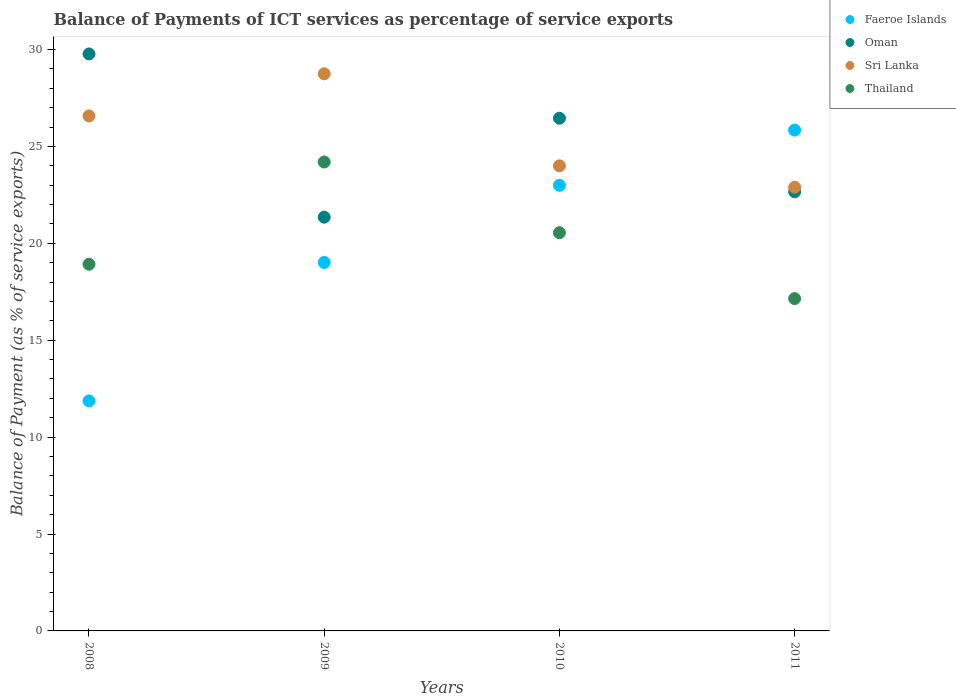How many different coloured dotlines are there?
Make the answer very short. 4. What is the balance of payments of ICT services in Faeroe Islands in 2011?
Offer a very short reply. 25.84. Across all years, what is the maximum balance of payments of ICT services in Thailand?
Your answer should be very brief. 24.19. Across all years, what is the minimum balance of payments of ICT services in Oman?
Offer a very short reply. 21.35. What is the total balance of payments of ICT services in Sri Lanka in the graph?
Give a very brief answer. 102.21. What is the difference between the balance of payments of ICT services in Faeroe Islands in 2010 and that in 2011?
Offer a very short reply. -2.85. What is the difference between the balance of payments of ICT services in Thailand in 2011 and the balance of payments of ICT services in Sri Lanka in 2009?
Your answer should be very brief. -11.6. What is the average balance of payments of ICT services in Thailand per year?
Provide a succinct answer. 20.2. In the year 2010, what is the difference between the balance of payments of ICT services in Oman and balance of payments of ICT services in Sri Lanka?
Provide a short and direct response. 2.46. What is the ratio of the balance of payments of ICT services in Sri Lanka in 2009 to that in 2011?
Provide a succinct answer. 1.26. Is the balance of payments of ICT services in Sri Lanka in 2008 less than that in 2011?
Provide a succinct answer. No. Is the difference between the balance of payments of ICT services in Oman in 2008 and 2009 greater than the difference between the balance of payments of ICT services in Sri Lanka in 2008 and 2009?
Make the answer very short. Yes. What is the difference between the highest and the second highest balance of payments of ICT services in Faeroe Islands?
Provide a short and direct response. 2.85. What is the difference between the highest and the lowest balance of payments of ICT services in Sri Lanka?
Give a very brief answer. 5.85. In how many years, is the balance of payments of ICT services in Oman greater than the average balance of payments of ICT services in Oman taken over all years?
Your response must be concise. 2. Is the balance of payments of ICT services in Sri Lanka strictly greater than the balance of payments of ICT services in Thailand over the years?
Your answer should be very brief. Yes. How many dotlines are there?
Ensure brevity in your answer.  4. What is the difference between two consecutive major ticks on the Y-axis?
Your response must be concise. 5. Does the graph contain any zero values?
Provide a short and direct response. No. Where does the legend appear in the graph?
Provide a succinct answer. Top right. How are the legend labels stacked?
Your response must be concise. Vertical. What is the title of the graph?
Your answer should be very brief. Balance of Payments of ICT services as percentage of service exports. Does "Other small states" appear as one of the legend labels in the graph?
Provide a succinct answer. No. What is the label or title of the X-axis?
Provide a succinct answer. Years. What is the label or title of the Y-axis?
Give a very brief answer. Balance of Payment (as % of service exports). What is the Balance of Payment (as % of service exports) of Faeroe Islands in 2008?
Ensure brevity in your answer.  11.87. What is the Balance of Payment (as % of service exports) in Oman in 2008?
Make the answer very short. 29.77. What is the Balance of Payment (as % of service exports) in Sri Lanka in 2008?
Make the answer very short. 26.57. What is the Balance of Payment (as % of service exports) in Thailand in 2008?
Provide a succinct answer. 18.92. What is the Balance of Payment (as % of service exports) of Faeroe Islands in 2009?
Offer a terse response. 19.01. What is the Balance of Payment (as % of service exports) in Oman in 2009?
Offer a very short reply. 21.35. What is the Balance of Payment (as % of service exports) of Sri Lanka in 2009?
Your response must be concise. 28.75. What is the Balance of Payment (as % of service exports) of Thailand in 2009?
Offer a very short reply. 24.19. What is the Balance of Payment (as % of service exports) in Faeroe Islands in 2010?
Make the answer very short. 22.99. What is the Balance of Payment (as % of service exports) of Oman in 2010?
Ensure brevity in your answer.  26.45. What is the Balance of Payment (as % of service exports) in Sri Lanka in 2010?
Make the answer very short. 24. What is the Balance of Payment (as % of service exports) in Thailand in 2010?
Offer a terse response. 20.55. What is the Balance of Payment (as % of service exports) of Faeroe Islands in 2011?
Give a very brief answer. 25.84. What is the Balance of Payment (as % of service exports) in Oman in 2011?
Provide a succinct answer. 22.66. What is the Balance of Payment (as % of service exports) of Sri Lanka in 2011?
Your answer should be very brief. 22.89. What is the Balance of Payment (as % of service exports) in Thailand in 2011?
Provide a succinct answer. 17.15. Across all years, what is the maximum Balance of Payment (as % of service exports) of Faeroe Islands?
Your answer should be very brief. 25.84. Across all years, what is the maximum Balance of Payment (as % of service exports) of Oman?
Give a very brief answer. 29.77. Across all years, what is the maximum Balance of Payment (as % of service exports) of Sri Lanka?
Provide a short and direct response. 28.75. Across all years, what is the maximum Balance of Payment (as % of service exports) in Thailand?
Provide a short and direct response. 24.19. Across all years, what is the minimum Balance of Payment (as % of service exports) in Faeroe Islands?
Make the answer very short. 11.87. Across all years, what is the minimum Balance of Payment (as % of service exports) of Oman?
Your answer should be compact. 21.35. Across all years, what is the minimum Balance of Payment (as % of service exports) of Sri Lanka?
Offer a terse response. 22.89. Across all years, what is the minimum Balance of Payment (as % of service exports) of Thailand?
Make the answer very short. 17.15. What is the total Balance of Payment (as % of service exports) of Faeroe Islands in the graph?
Ensure brevity in your answer.  79.72. What is the total Balance of Payment (as % of service exports) in Oman in the graph?
Provide a short and direct response. 100.23. What is the total Balance of Payment (as % of service exports) of Sri Lanka in the graph?
Give a very brief answer. 102.21. What is the total Balance of Payment (as % of service exports) in Thailand in the graph?
Provide a succinct answer. 80.81. What is the difference between the Balance of Payment (as % of service exports) in Faeroe Islands in 2008 and that in 2009?
Ensure brevity in your answer.  -7.14. What is the difference between the Balance of Payment (as % of service exports) of Oman in 2008 and that in 2009?
Provide a short and direct response. 8.42. What is the difference between the Balance of Payment (as % of service exports) of Sri Lanka in 2008 and that in 2009?
Provide a succinct answer. -2.17. What is the difference between the Balance of Payment (as % of service exports) in Thailand in 2008 and that in 2009?
Give a very brief answer. -5.27. What is the difference between the Balance of Payment (as % of service exports) of Faeroe Islands in 2008 and that in 2010?
Give a very brief answer. -11.13. What is the difference between the Balance of Payment (as % of service exports) in Oman in 2008 and that in 2010?
Offer a very short reply. 3.32. What is the difference between the Balance of Payment (as % of service exports) in Sri Lanka in 2008 and that in 2010?
Give a very brief answer. 2.58. What is the difference between the Balance of Payment (as % of service exports) of Thailand in 2008 and that in 2010?
Make the answer very short. -1.63. What is the difference between the Balance of Payment (as % of service exports) in Faeroe Islands in 2008 and that in 2011?
Your answer should be very brief. -13.97. What is the difference between the Balance of Payment (as % of service exports) in Oman in 2008 and that in 2011?
Your answer should be very brief. 7.11. What is the difference between the Balance of Payment (as % of service exports) of Sri Lanka in 2008 and that in 2011?
Provide a succinct answer. 3.68. What is the difference between the Balance of Payment (as % of service exports) in Thailand in 2008 and that in 2011?
Give a very brief answer. 1.77. What is the difference between the Balance of Payment (as % of service exports) of Faeroe Islands in 2009 and that in 2010?
Your answer should be compact. -3.98. What is the difference between the Balance of Payment (as % of service exports) in Oman in 2009 and that in 2010?
Make the answer very short. -5.11. What is the difference between the Balance of Payment (as % of service exports) in Sri Lanka in 2009 and that in 2010?
Offer a terse response. 4.75. What is the difference between the Balance of Payment (as % of service exports) of Thailand in 2009 and that in 2010?
Provide a short and direct response. 3.65. What is the difference between the Balance of Payment (as % of service exports) in Faeroe Islands in 2009 and that in 2011?
Offer a terse response. -6.83. What is the difference between the Balance of Payment (as % of service exports) of Oman in 2009 and that in 2011?
Ensure brevity in your answer.  -1.31. What is the difference between the Balance of Payment (as % of service exports) in Sri Lanka in 2009 and that in 2011?
Give a very brief answer. 5.85. What is the difference between the Balance of Payment (as % of service exports) of Thailand in 2009 and that in 2011?
Give a very brief answer. 7.05. What is the difference between the Balance of Payment (as % of service exports) in Faeroe Islands in 2010 and that in 2011?
Your answer should be very brief. -2.85. What is the difference between the Balance of Payment (as % of service exports) of Oman in 2010 and that in 2011?
Your answer should be very brief. 3.79. What is the difference between the Balance of Payment (as % of service exports) of Sri Lanka in 2010 and that in 2011?
Provide a short and direct response. 1.1. What is the difference between the Balance of Payment (as % of service exports) of Thailand in 2010 and that in 2011?
Your response must be concise. 3.4. What is the difference between the Balance of Payment (as % of service exports) in Faeroe Islands in 2008 and the Balance of Payment (as % of service exports) in Oman in 2009?
Offer a very short reply. -9.48. What is the difference between the Balance of Payment (as % of service exports) of Faeroe Islands in 2008 and the Balance of Payment (as % of service exports) of Sri Lanka in 2009?
Your answer should be compact. -16.88. What is the difference between the Balance of Payment (as % of service exports) of Faeroe Islands in 2008 and the Balance of Payment (as % of service exports) of Thailand in 2009?
Keep it short and to the point. -12.33. What is the difference between the Balance of Payment (as % of service exports) of Oman in 2008 and the Balance of Payment (as % of service exports) of Sri Lanka in 2009?
Offer a terse response. 1.03. What is the difference between the Balance of Payment (as % of service exports) in Oman in 2008 and the Balance of Payment (as % of service exports) in Thailand in 2009?
Keep it short and to the point. 5.58. What is the difference between the Balance of Payment (as % of service exports) in Sri Lanka in 2008 and the Balance of Payment (as % of service exports) in Thailand in 2009?
Make the answer very short. 2.38. What is the difference between the Balance of Payment (as % of service exports) of Faeroe Islands in 2008 and the Balance of Payment (as % of service exports) of Oman in 2010?
Your answer should be compact. -14.59. What is the difference between the Balance of Payment (as % of service exports) in Faeroe Islands in 2008 and the Balance of Payment (as % of service exports) in Sri Lanka in 2010?
Provide a succinct answer. -12.13. What is the difference between the Balance of Payment (as % of service exports) in Faeroe Islands in 2008 and the Balance of Payment (as % of service exports) in Thailand in 2010?
Your response must be concise. -8.68. What is the difference between the Balance of Payment (as % of service exports) in Oman in 2008 and the Balance of Payment (as % of service exports) in Sri Lanka in 2010?
Give a very brief answer. 5.77. What is the difference between the Balance of Payment (as % of service exports) of Oman in 2008 and the Balance of Payment (as % of service exports) of Thailand in 2010?
Keep it short and to the point. 9.22. What is the difference between the Balance of Payment (as % of service exports) in Sri Lanka in 2008 and the Balance of Payment (as % of service exports) in Thailand in 2010?
Provide a short and direct response. 6.03. What is the difference between the Balance of Payment (as % of service exports) of Faeroe Islands in 2008 and the Balance of Payment (as % of service exports) of Oman in 2011?
Provide a short and direct response. -10.79. What is the difference between the Balance of Payment (as % of service exports) of Faeroe Islands in 2008 and the Balance of Payment (as % of service exports) of Sri Lanka in 2011?
Offer a terse response. -11.02. What is the difference between the Balance of Payment (as % of service exports) of Faeroe Islands in 2008 and the Balance of Payment (as % of service exports) of Thailand in 2011?
Provide a succinct answer. -5.28. What is the difference between the Balance of Payment (as % of service exports) of Oman in 2008 and the Balance of Payment (as % of service exports) of Sri Lanka in 2011?
Provide a succinct answer. 6.88. What is the difference between the Balance of Payment (as % of service exports) in Oman in 2008 and the Balance of Payment (as % of service exports) in Thailand in 2011?
Your response must be concise. 12.63. What is the difference between the Balance of Payment (as % of service exports) of Sri Lanka in 2008 and the Balance of Payment (as % of service exports) of Thailand in 2011?
Provide a succinct answer. 9.43. What is the difference between the Balance of Payment (as % of service exports) in Faeroe Islands in 2009 and the Balance of Payment (as % of service exports) in Oman in 2010?
Give a very brief answer. -7.44. What is the difference between the Balance of Payment (as % of service exports) of Faeroe Islands in 2009 and the Balance of Payment (as % of service exports) of Sri Lanka in 2010?
Your response must be concise. -4.99. What is the difference between the Balance of Payment (as % of service exports) in Faeroe Islands in 2009 and the Balance of Payment (as % of service exports) in Thailand in 2010?
Your answer should be compact. -1.53. What is the difference between the Balance of Payment (as % of service exports) of Oman in 2009 and the Balance of Payment (as % of service exports) of Sri Lanka in 2010?
Offer a very short reply. -2.65. What is the difference between the Balance of Payment (as % of service exports) of Oman in 2009 and the Balance of Payment (as % of service exports) of Thailand in 2010?
Offer a terse response. 0.8. What is the difference between the Balance of Payment (as % of service exports) of Sri Lanka in 2009 and the Balance of Payment (as % of service exports) of Thailand in 2010?
Ensure brevity in your answer.  8.2. What is the difference between the Balance of Payment (as % of service exports) of Faeroe Islands in 2009 and the Balance of Payment (as % of service exports) of Oman in 2011?
Your answer should be very brief. -3.65. What is the difference between the Balance of Payment (as % of service exports) in Faeroe Islands in 2009 and the Balance of Payment (as % of service exports) in Sri Lanka in 2011?
Provide a short and direct response. -3.88. What is the difference between the Balance of Payment (as % of service exports) in Faeroe Islands in 2009 and the Balance of Payment (as % of service exports) in Thailand in 2011?
Provide a succinct answer. 1.87. What is the difference between the Balance of Payment (as % of service exports) in Oman in 2009 and the Balance of Payment (as % of service exports) in Sri Lanka in 2011?
Make the answer very short. -1.54. What is the difference between the Balance of Payment (as % of service exports) of Oman in 2009 and the Balance of Payment (as % of service exports) of Thailand in 2011?
Your response must be concise. 4.2. What is the difference between the Balance of Payment (as % of service exports) of Sri Lanka in 2009 and the Balance of Payment (as % of service exports) of Thailand in 2011?
Give a very brief answer. 11.6. What is the difference between the Balance of Payment (as % of service exports) of Faeroe Islands in 2010 and the Balance of Payment (as % of service exports) of Oman in 2011?
Keep it short and to the point. 0.33. What is the difference between the Balance of Payment (as % of service exports) in Faeroe Islands in 2010 and the Balance of Payment (as % of service exports) in Sri Lanka in 2011?
Ensure brevity in your answer.  0.1. What is the difference between the Balance of Payment (as % of service exports) in Faeroe Islands in 2010 and the Balance of Payment (as % of service exports) in Thailand in 2011?
Offer a terse response. 5.85. What is the difference between the Balance of Payment (as % of service exports) in Oman in 2010 and the Balance of Payment (as % of service exports) in Sri Lanka in 2011?
Your answer should be compact. 3.56. What is the difference between the Balance of Payment (as % of service exports) of Oman in 2010 and the Balance of Payment (as % of service exports) of Thailand in 2011?
Offer a very short reply. 9.31. What is the difference between the Balance of Payment (as % of service exports) of Sri Lanka in 2010 and the Balance of Payment (as % of service exports) of Thailand in 2011?
Give a very brief answer. 6.85. What is the average Balance of Payment (as % of service exports) in Faeroe Islands per year?
Provide a succinct answer. 19.93. What is the average Balance of Payment (as % of service exports) in Oman per year?
Offer a terse response. 25.06. What is the average Balance of Payment (as % of service exports) in Sri Lanka per year?
Ensure brevity in your answer.  25.55. What is the average Balance of Payment (as % of service exports) of Thailand per year?
Give a very brief answer. 20.2. In the year 2008, what is the difference between the Balance of Payment (as % of service exports) in Faeroe Islands and Balance of Payment (as % of service exports) in Oman?
Make the answer very short. -17.9. In the year 2008, what is the difference between the Balance of Payment (as % of service exports) of Faeroe Islands and Balance of Payment (as % of service exports) of Sri Lanka?
Provide a short and direct response. -14.7. In the year 2008, what is the difference between the Balance of Payment (as % of service exports) of Faeroe Islands and Balance of Payment (as % of service exports) of Thailand?
Your answer should be compact. -7.05. In the year 2008, what is the difference between the Balance of Payment (as % of service exports) of Oman and Balance of Payment (as % of service exports) of Sri Lanka?
Offer a terse response. 3.2. In the year 2008, what is the difference between the Balance of Payment (as % of service exports) of Oman and Balance of Payment (as % of service exports) of Thailand?
Ensure brevity in your answer.  10.85. In the year 2008, what is the difference between the Balance of Payment (as % of service exports) in Sri Lanka and Balance of Payment (as % of service exports) in Thailand?
Provide a short and direct response. 7.65. In the year 2009, what is the difference between the Balance of Payment (as % of service exports) of Faeroe Islands and Balance of Payment (as % of service exports) of Oman?
Provide a short and direct response. -2.34. In the year 2009, what is the difference between the Balance of Payment (as % of service exports) of Faeroe Islands and Balance of Payment (as % of service exports) of Sri Lanka?
Ensure brevity in your answer.  -9.73. In the year 2009, what is the difference between the Balance of Payment (as % of service exports) in Faeroe Islands and Balance of Payment (as % of service exports) in Thailand?
Provide a short and direct response. -5.18. In the year 2009, what is the difference between the Balance of Payment (as % of service exports) in Oman and Balance of Payment (as % of service exports) in Sri Lanka?
Offer a terse response. -7.4. In the year 2009, what is the difference between the Balance of Payment (as % of service exports) in Oman and Balance of Payment (as % of service exports) in Thailand?
Your answer should be very brief. -2.85. In the year 2009, what is the difference between the Balance of Payment (as % of service exports) of Sri Lanka and Balance of Payment (as % of service exports) of Thailand?
Your answer should be compact. 4.55. In the year 2010, what is the difference between the Balance of Payment (as % of service exports) of Faeroe Islands and Balance of Payment (as % of service exports) of Oman?
Make the answer very short. -3.46. In the year 2010, what is the difference between the Balance of Payment (as % of service exports) of Faeroe Islands and Balance of Payment (as % of service exports) of Sri Lanka?
Your answer should be compact. -1. In the year 2010, what is the difference between the Balance of Payment (as % of service exports) in Faeroe Islands and Balance of Payment (as % of service exports) in Thailand?
Provide a succinct answer. 2.45. In the year 2010, what is the difference between the Balance of Payment (as % of service exports) of Oman and Balance of Payment (as % of service exports) of Sri Lanka?
Provide a succinct answer. 2.46. In the year 2010, what is the difference between the Balance of Payment (as % of service exports) in Oman and Balance of Payment (as % of service exports) in Thailand?
Make the answer very short. 5.91. In the year 2010, what is the difference between the Balance of Payment (as % of service exports) in Sri Lanka and Balance of Payment (as % of service exports) in Thailand?
Make the answer very short. 3.45. In the year 2011, what is the difference between the Balance of Payment (as % of service exports) of Faeroe Islands and Balance of Payment (as % of service exports) of Oman?
Provide a short and direct response. 3.18. In the year 2011, what is the difference between the Balance of Payment (as % of service exports) of Faeroe Islands and Balance of Payment (as % of service exports) of Sri Lanka?
Give a very brief answer. 2.95. In the year 2011, what is the difference between the Balance of Payment (as % of service exports) in Faeroe Islands and Balance of Payment (as % of service exports) in Thailand?
Make the answer very short. 8.7. In the year 2011, what is the difference between the Balance of Payment (as % of service exports) of Oman and Balance of Payment (as % of service exports) of Sri Lanka?
Your response must be concise. -0.23. In the year 2011, what is the difference between the Balance of Payment (as % of service exports) in Oman and Balance of Payment (as % of service exports) in Thailand?
Keep it short and to the point. 5.51. In the year 2011, what is the difference between the Balance of Payment (as % of service exports) in Sri Lanka and Balance of Payment (as % of service exports) in Thailand?
Provide a short and direct response. 5.75. What is the ratio of the Balance of Payment (as % of service exports) of Faeroe Islands in 2008 to that in 2009?
Ensure brevity in your answer.  0.62. What is the ratio of the Balance of Payment (as % of service exports) of Oman in 2008 to that in 2009?
Offer a terse response. 1.39. What is the ratio of the Balance of Payment (as % of service exports) in Sri Lanka in 2008 to that in 2009?
Offer a very short reply. 0.92. What is the ratio of the Balance of Payment (as % of service exports) in Thailand in 2008 to that in 2009?
Your response must be concise. 0.78. What is the ratio of the Balance of Payment (as % of service exports) of Faeroe Islands in 2008 to that in 2010?
Make the answer very short. 0.52. What is the ratio of the Balance of Payment (as % of service exports) in Oman in 2008 to that in 2010?
Give a very brief answer. 1.13. What is the ratio of the Balance of Payment (as % of service exports) of Sri Lanka in 2008 to that in 2010?
Your response must be concise. 1.11. What is the ratio of the Balance of Payment (as % of service exports) of Thailand in 2008 to that in 2010?
Make the answer very short. 0.92. What is the ratio of the Balance of Payment (as % of service exports) in Faeroe Islands in 2008 to that in 2011?
Your answer should be very brief. 0.46. What is the ratio of the Balance of Payment (as % of service exports) of Oman in 2008 to that in 2011?
Keep it short and to the point. 1.31. What is the ratio of the Balance of Payment (as % of service exports) in Sri Lanka in 2008 to that in 2011?
Give a very brief answer. 1.16. What is the ratio of the Balance of Payment (as % of service exports) in Thailand in 2008 to that in 2011?
Keep it short and to the point. 1.1. What is the ratio of the Balance of Payment (as % of service exports) in Faeroe Islands in 2009 to that in 2010?
Make the answer very short. 0.83. What is the ratio of the Balance of Payment (as % of service exports) in Oman in 2009 to that in 2010?
Ensure brevity in your answer.  0.81. What is the ratio of the Balance of Payment (as % of service exports) of Sri Lanka in 2009 to that in 2010?
Your response must be concise. 1.2. What is the ratio of the Balance of Payment (as % of service exports) in Thailand in 2009 to that in 2010?
Your answer should be compact. 1.18. What is the ratio of the Balance of Payment (as % of service exports) in Faeroe Islands in 2009 to that in 2011?
Make the answer very short. 0.74. What is the ratio of the Balance of Payment (as % of service exports) of Oman in 2009 to that in 2011?
Provide a short and direct response. 0.94. What is the ratio of the Balance of Payment (as % of service exports) in Sri Lanka in 2009 to that in 2011?
Offer a very short reply. 1.26. What is the ratio of the Balance of Payment (as % of service exports) of Thailand in 2009 to that in 2011?
Your answer should be compact. 1.41. What is the ratio of the Balance of Payment (as % of service exports) in Faeroe Islands in 2010 to that in 2011?
Your response must be concise. 0.89. What is the ratio of the Balance of Payment (as % of service exports) of Oman in 2010 to that in 2011?
Keep it short and to the point. 1.17. What is the ratio of the Balance of Payment (as % of service exports) in Sri Lanka in 2010 to that in 2011?
Your response must be concise. 1.05. What is the ratio of the Balance of Payment (as % of service exports) in Thailand in 2010 to that in 2011?
Your answer should be very brief. 1.2. What is the difference between the highest and the second highest Balance of Payment (as % of service exports) in Faeroe Islands?
Your response must be concise. 2.85. What is the difference between the highest and the second highest Balance of Payment (as % of service exports) in Oman?
Give a very brief answer. 3.32. What is the difference between the highest and the second highest Balance of Payment (as % of service exports) in Sri Lanka?
Offer a terse response. 2.17. What is the difference between the highest and the second highest Balance of Payment (as % of service exports) of Thailand?
Your answer should be compact. 3.65. What is the difference between the highest and the lowest Balance of Payment (as % of service exports) of Faeroe Islands?
Make the answer very short. 13.97. What is the difference between the highest and the lowest Balance of Payment (as % of service exports) in Oman?
Your response must be concise. 8.42. What is the difference between the highest and the lowest Balance of Payment (as % of service exports) in Sri Lanka?
Offer a terse response. 5.85. What is the difference between the highest and the lowest Balance of Payment (as % of service exports) in Thailand?
Provide a short and direct response. 7.05. 